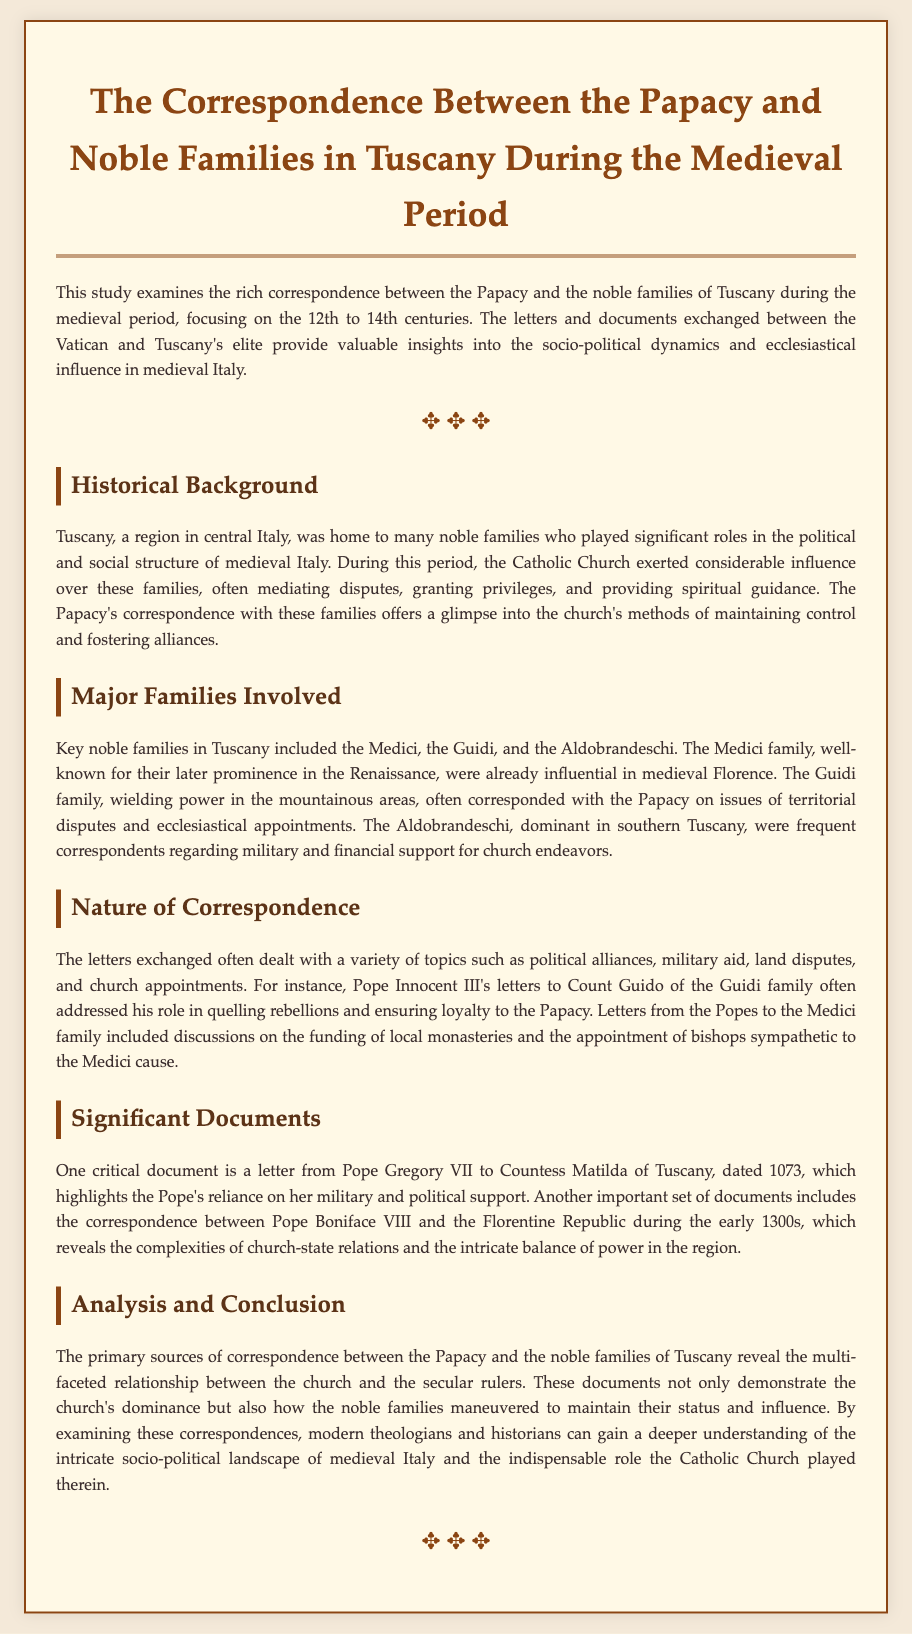What time period does the study focus on? The study examines the correspondence during the 12th to 14th centuries.
Answer: 12th to 14th centuries Which family is associated with Florence? The Medici family is well-known for their later prominence in Florence.
Answer: Medici Who wrote a letter to Countess Matilda of Tuscany? Pope Gregory VII wrote to Countess Matilda of Tuscany in 1073.
Answer: Pope Gregory VII What was a significant topic addressed in the correspondence? The letters often addressed political alliances and church appointments.
Answer: Political alliances and church appointments Which family frequently corresponded about military and financial support? The Aldobrandeschi family frequently corresponded regarding military and financial support.
Answer: Aldobrandeschi What was a role discussed in letters to Count Guido of the Guidi family? The letters addressed his role in quelling rebellions and ensuring loyalty.
Answer: Quelling rebellions and ensuring loyalty What does the document suggest about the Catholic Church's role? The document highlights the church's dominance and influence in medieval Tuscany.
Answer: Church's dominance and influence Which Pope's letters included discussions on local monasteries? Letters from Pope Innocent III to the Medici included discussions on monasteries.
Answer: Pope Innocent III What type of documents are analyzed in the study? The study analyzes primary sources of correspondence between the Papacy and noble families.
Answer: Primary sources of correspondence 